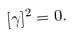<formula> <loc_0><loc_0><loc_500><loc_500>[ \gamma ] ^ { 2 } = 0 .</formula> 